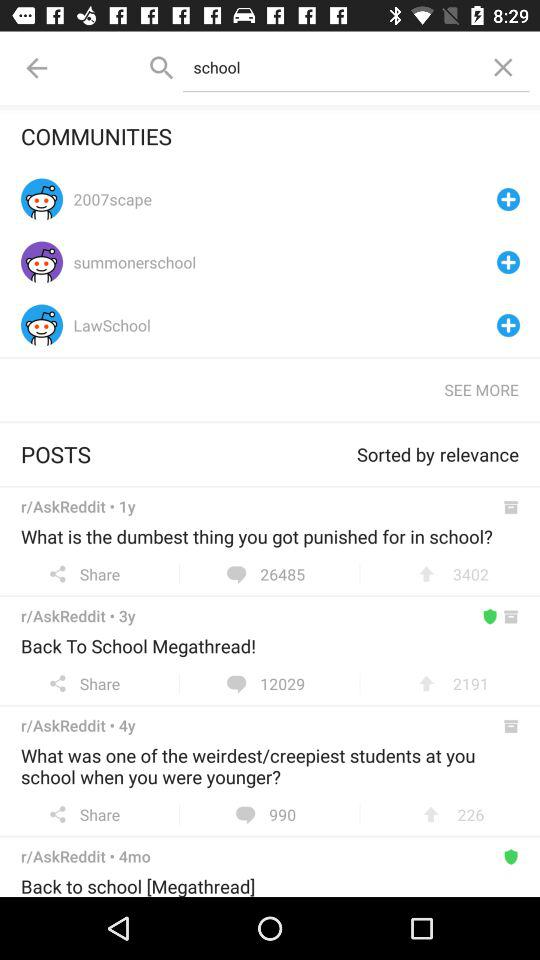What are the different communities? The different communities are "2007scape", "summonerschool", and "LawSchool". 